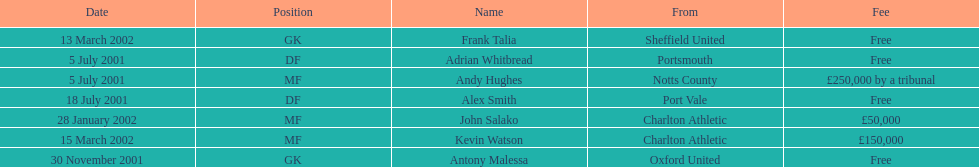Did andy hughes or john salako command the largest fee? Andy Hughes. 